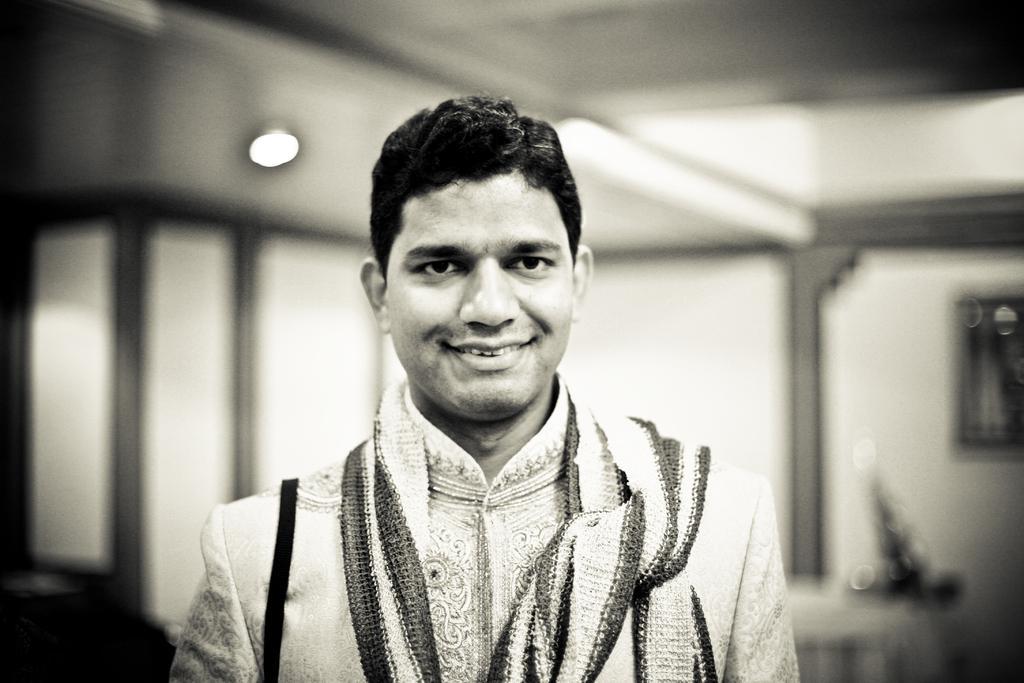Could you give a brief overview of what you see in this image? In this image I can see in the middle there is a man, he is smiling, at the back side it looks like a light. This image is in black and white color. 